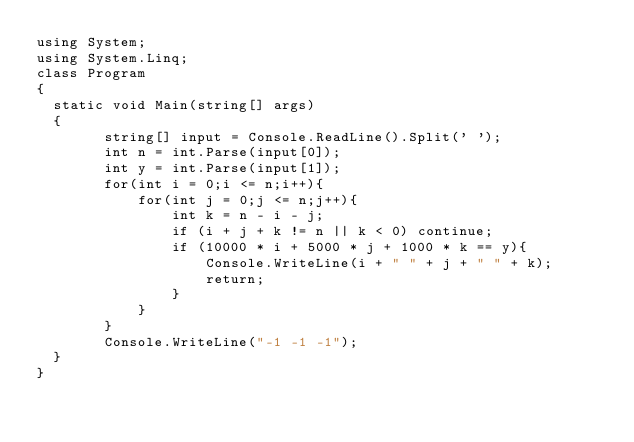<code> <loc_0><loc_0><loc_500><loc_500><_C#_>using System;
using System.Linq;
class Program
{
	static void Main(string[] args)
	{
        string[] input = Console.ReadLine().Split(' ');
        int n = int.Parse(input[0]);
        int y = int.Parse(input[1]);
        for(int i = 0;i <= n;i++){
            for(int j = 0;j <= n;j++){
                int k = n - i - j;
                if (i + j + k != n || k < 0) continue;
                if (10000 * i + 5000 * j + 1000 * k == y){
                    Console.WriteLine(i + " " + j + " " + k);
                    return;
                }
            }
        }
        Console.WriteLine("-1 -1 -1");
	}
}</code> 